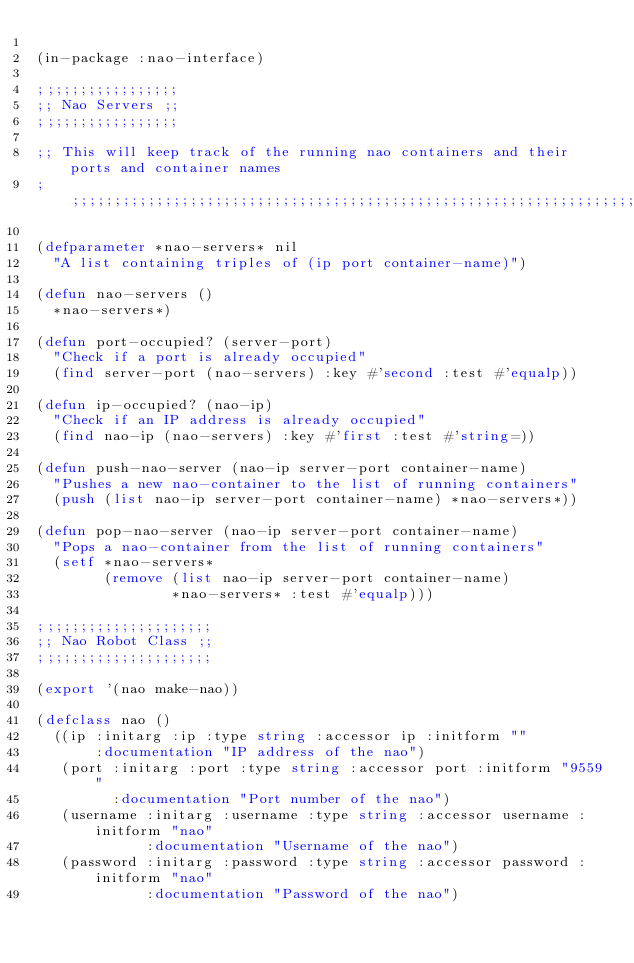Convert code to text. <code><loc_0><loc_0><loc_500><loc_500><_Lisp_>
(in-package :nao-interface)

;;;;;;;;;;;;;;;;;
;; Nao Servers ;;
;;;;;;;;;;;;;;;;;

;; This will keep track of the running nao containers and their ports and container names
;;;;;;;;;;;;;;;;;;;;;;;;;;;;;;;;;;;;;;;;;;;;;;;;;;;;;;;;;;;;;;;;;;;;;;;;;;;;;;;;;;;;;;;;;

(defparameter *nao-servers* nil
  "A list containing triples of (ip port container-name)")

(defun nao-servers ()
  *nao-servers*)

(defun port-occupied? (server-port)
  "Check if a port is already occupied"
  (find server-port (nao-servers) :key #'second :test #'equalp))

(defun ip-occupied? (nao-ip)
  "Check if an IP address is already occupied"
  (find nao-ip (nao-servers) :key #'first :test #'string=))

(defun push-nao-server (nao-ip server-port container-name)
  "Pushes a new nao-container to the list of running containers"
  (push (list nao-ip server-port container-name) *nao-servers*))

(defun pop-nao-server (nao-ip server-port container-name)
  "Pops a nao-container from the list of running containers"
  (setf *nao-servers*
        (remove (list nao-ip server-port container-name)
                *nao-servers* :test #'equalp)))

;;;;;;;;;;;;;;;;;;;;;
;; Nao Robot Class ;;
;;;;;;;;;;;;;;;;;;;;;

(export '(nao make-nao))

(defclass nao ()
  ((ip :initarg :ip :type string :accessor ip :initform ""
       :documentation "IP address of the nao")
   (port :initarg :port :type string :accessor port :initform "9559"
         :documentation "Port number of the nao")
   (username :initarg :username :type string :accessor username :initform "nao"
             :documentation "Username of the nao")
   (password :initarg :password :type string :accessor password :initform "nao"
             :documentation "Password of the nao")</code> 